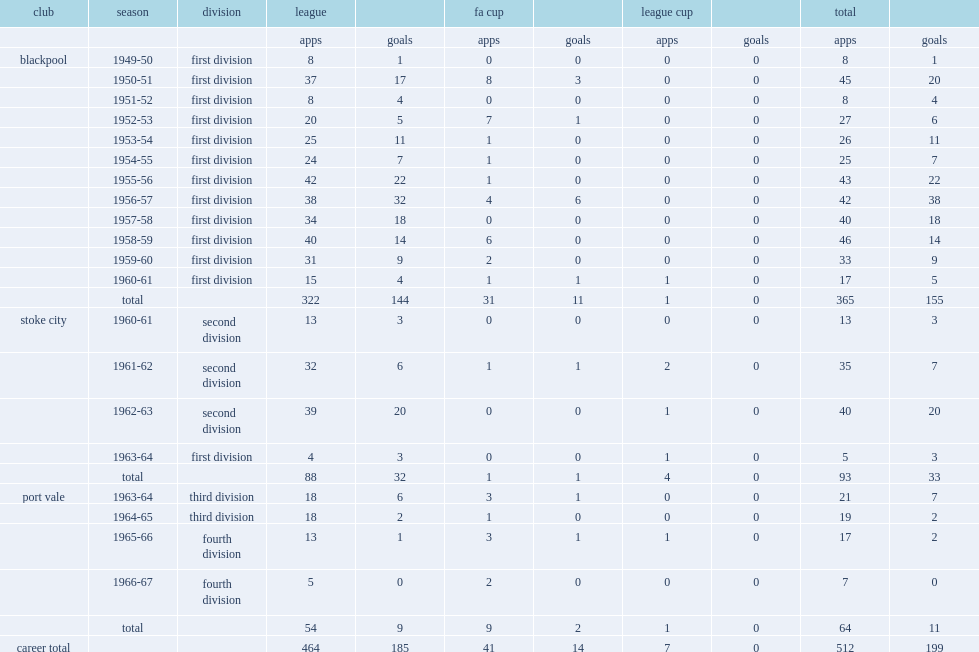How many league goals did jackie mudie score a total of for the blackpool? 144.0. 